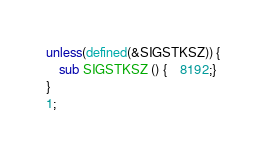<code> <loc_0><loc_0><loc_500><loc_500><_Perl_>unless(defined(&SIGSTKSZ)) {
    sub SIGSTKSZ () {	8192;}
}
1;
</code> 